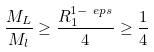Convert formula to latex. <formula><loc_0><loc_0><loc_500><loc_500>\frac { M _ { L } } { M _ { l } } \geq \frac { R _ { 1 } ^ { 1 - \ e p s } } { 4 } \geq \frac { 1 } { 4 }</formula> 